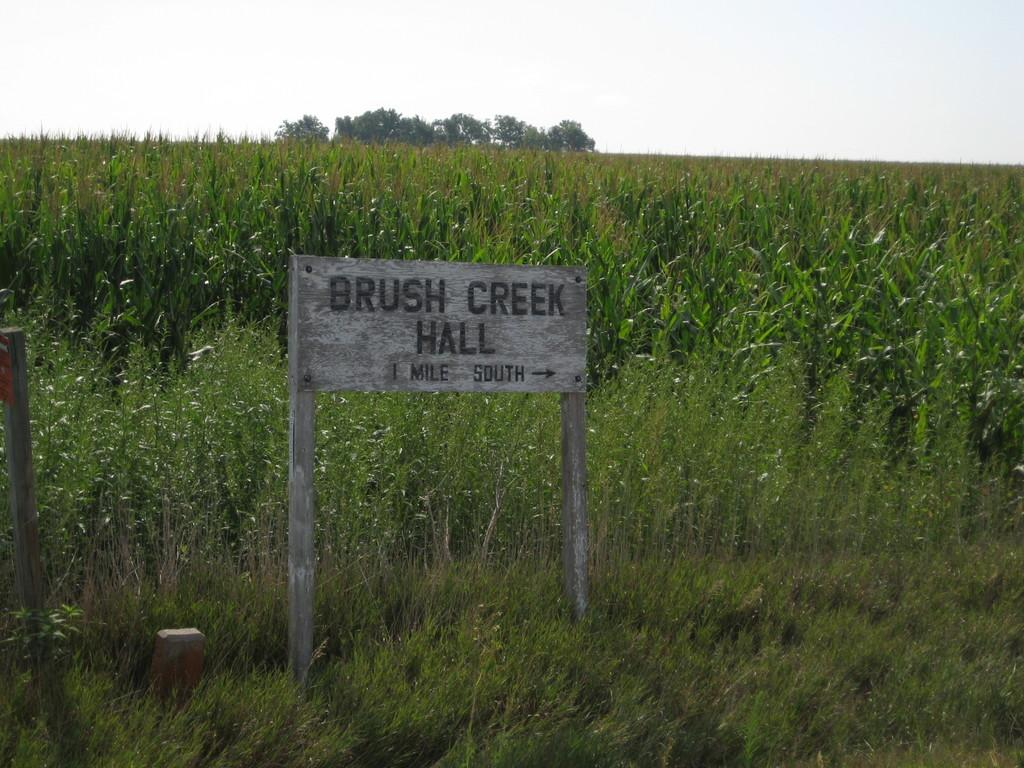What is the main object in the image? There is a name board in the image. What else can be seen in the image besides the name board? There are poles, plants, and trees in the image. What is visible in the background of the image? The sky is visible in the background of the image. What type of eye can be seen on the name board in the image? There is no eye present on the name board in the image. What kind of heart-shaped object is visible in the image? There is no heart-shaped object present in the image. 